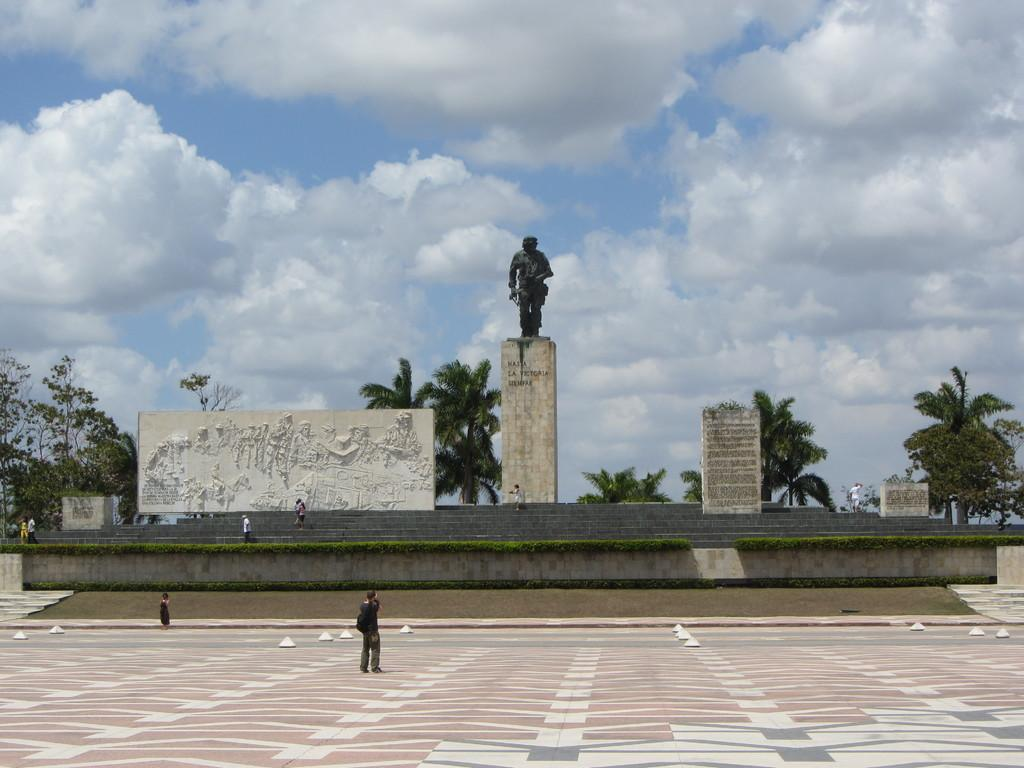Where was the image taken? The image was clicked outside. What can be seen in the middle of the image? There are trees and a statue in the middle of the image. What is visible on the left side of the image? There are some persons on the left side of the image. What is visible at the top of the image? The sky is visible at the top of the image. What color is the blood on the statue in the image? There is no blood present on the statue in the image. How does the fog affect the visibility of the trees in the image? There is no fog present in the image, so it does not affect the visibility of the trees. 